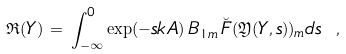Convert formula to latex. <formula><loc_0><loc_0><loc_500><loc_500>\mathfrak { R } ( Y ) \, = \, \int _ { - \infty } ^ { 0 } \exp ( - s k A ) \, B _ { 1 m } \, \breve { F } ( \mathfrak { Y } ( Y , s ) ) _ { m } d s \ ,</formula> 